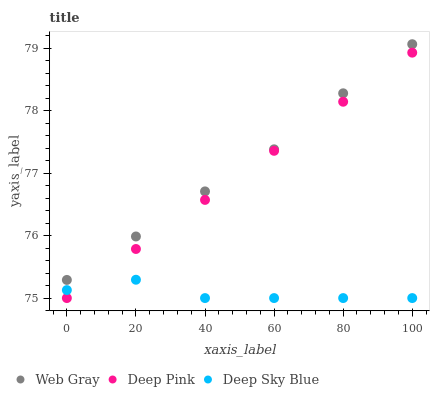Does Deep Sky Blue have the minimum area under the curve?
Answer yes or no. Yes. Does Web Gray have the maximum area under the curve?
Answer yes or no. Yes. Does Deep Pink have the minimum area under the curve?
Answer yes or no. No. Does Deep Pink have the maximum area under the curve?
Answer yes or no. No. Is Deep Pink the smoothest?
Answer yes or no. Yes. Is Deep Sky Blue the roughest?
Answer yes or no. Yes. Is Deep Sky Blue the smoothest?
Answer yes or no. No. Is Deep Pink the roughest?
Answer yes or no. No. Does Deep Sky Blue have the lowest value?
Answer yes or no. Yes. Does Web Gray have the highest value?
Answer yes or no. Yes. Does Deep Pink have the highest value?
Answer yes or no. No. Is Deep Sky Blue less than Web Gray?
Answer yes or no. Yes. Is Web Gray greater than Deep Pink?
Answer yes or no. Yes. Does Deep Sky Blue intersect Deep Pink?
Answer yes or no. Yes. Is Deep Sky Blue less than Deep Pink?
Answer yes or no. No. Is Deep Sky Blue greater than Deep Pink?
Answer yes or no. No. Does Deep Sky Blue intersect Web Gray?
Answer yes or no. No. 